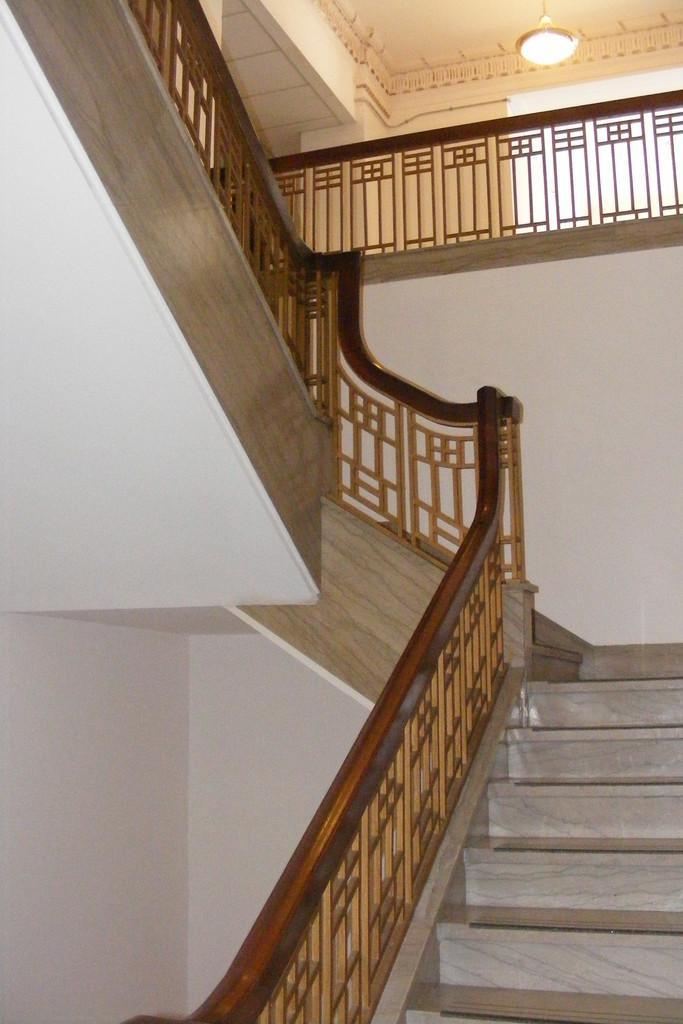In one or two sentences, can you explain what this image depicts? There is a staircase with railings. In the back there is a railing. On the ceiling there is a light. On the right side there is a wall. 